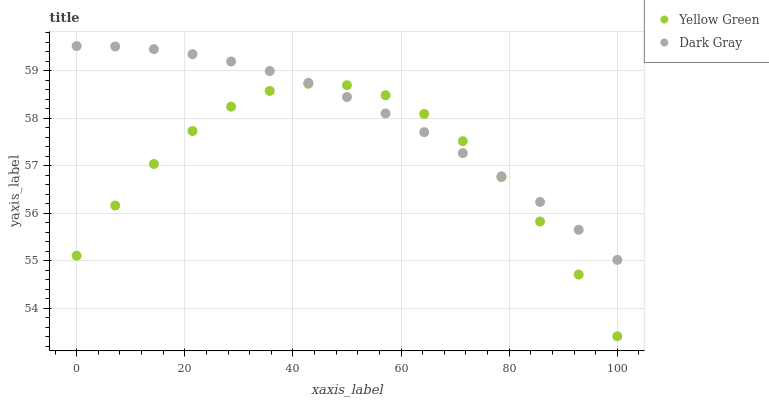Does Yellow Green have the minimum area under the curve?
Answer yes or no. Yes. Does Dark Gray have the maximum area under the curve?
Answer yes or no. Yes. Does Yellow Green have the maximum area under the curve?
Answer yes or no. No. Is Dark Gray the smoothest?
Answer yes or no. Yes. Is Yellow Green the roughest?
Answer yes or no. Yes. Is Yellow Green the smoothest?
Answer yes or no. No. Does Yellow Green have the lowest value?
Answer yes or no. Yes. Does Dark Gray have the highest value?
Answer yes or no. Yes. Does Yellow Green have the highest value?
Answer yes or no. No. Does Yellow Green intersect Dark Gray?
Answer yes or no. Yes. Is Yellow Green less than Dark Gray?
Answer yes or no. No. Is Yellow Green greater than Dark Gray?
Answer yes or no. No. 